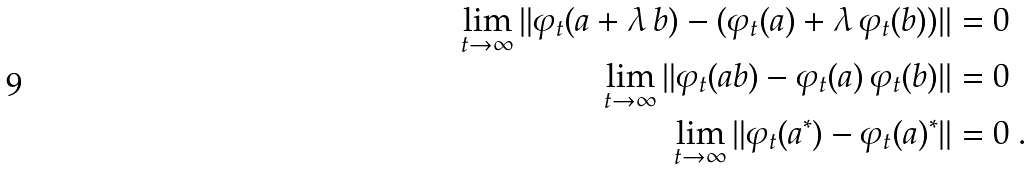<formula> <loc_0><loc_0><loc_500><loc_500>\lim _ { t \to \infty } \| \varphi _ { t } ( a + \lambda \, b ) - ( \varphi _ { t } ( a ) + \lambda \, \varphi _ { t } ( b ) ) \| & = 0 \\ \lim _ { t \to \infty } \| \varphi _ { t } ( a b ) - \varphi _ { t } ( a ) \, \varphi _ { t } ( b ) \| & = 0 \\ \lim _ { t \to \infty } \| \varphi _ { t } ( a ^ { * } ) - \varphi _ { t } ( a ) ^ { * } \| & = 0 \ .</formula> 